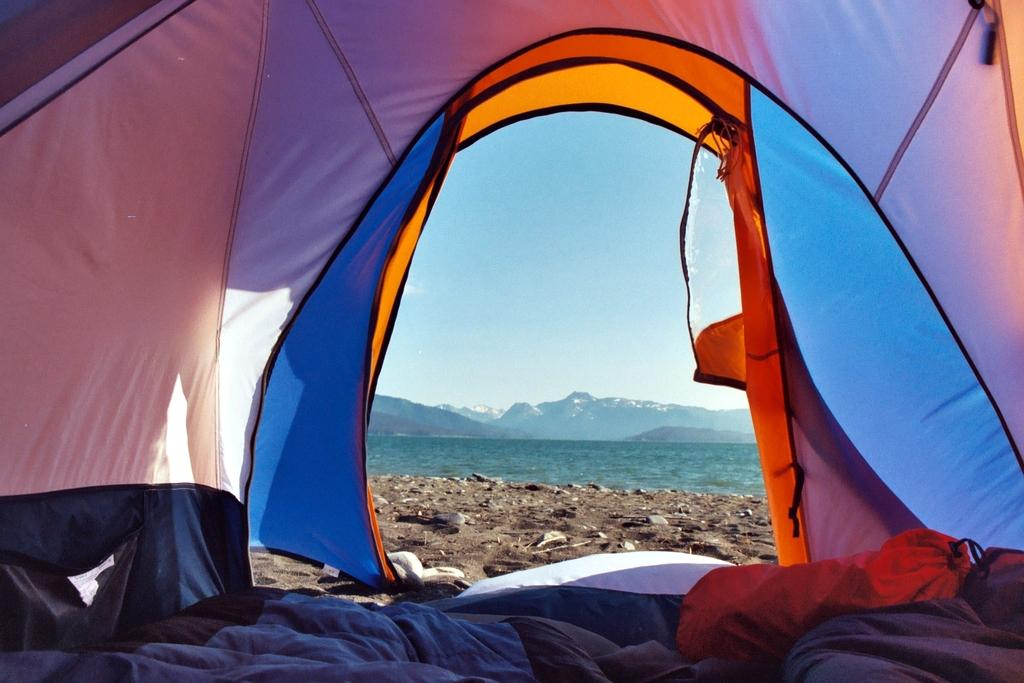What structure can be seen in the image? There is a tent in the image. What is the design of the tent? The tent has a multicolor design. What can be seen in the background of the image? There is water and mountains visible in the background of the image. What is the color of the sky in the image? The sky is blue in the image. What type of waste is being disposed of in the image? There is no waste present in the image; it features a tent with a multicolor design and a background of water, mountains, and a blue sky. 